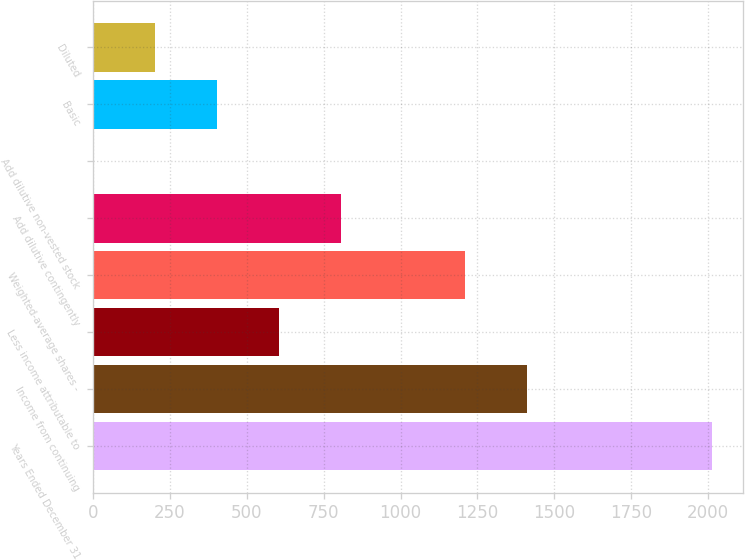<chart> <loc_0><loc_0><loc_500><loc_500><bar_chart><fcel>Years Ended December 31<fcel>Income from continuing<fcel>Less income attributable to<fcel>Weighted-average shares -<fcel>Add dilutive contingently<fcel>Add dilutive non-vested stock<fcel>Basic<fcel>Diluted<nl><fcel>2014<fcel>1410.07<fcel>604.83<fcel>1208.76<fcel>806.14<fcel>0.9<fcel>403.52<fcel>202.21<nl></chart> 